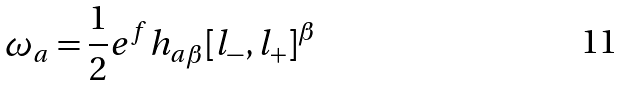Convert formula to latex. <formula><loc_0><loc_0><loc_500><loc_500>\omega _ { a } = \frac { 1 } { 2 } e ^ { f } h _ { a \beta } [ l _ { - } , l _ { + } ] ^ { \beta }</formula> 